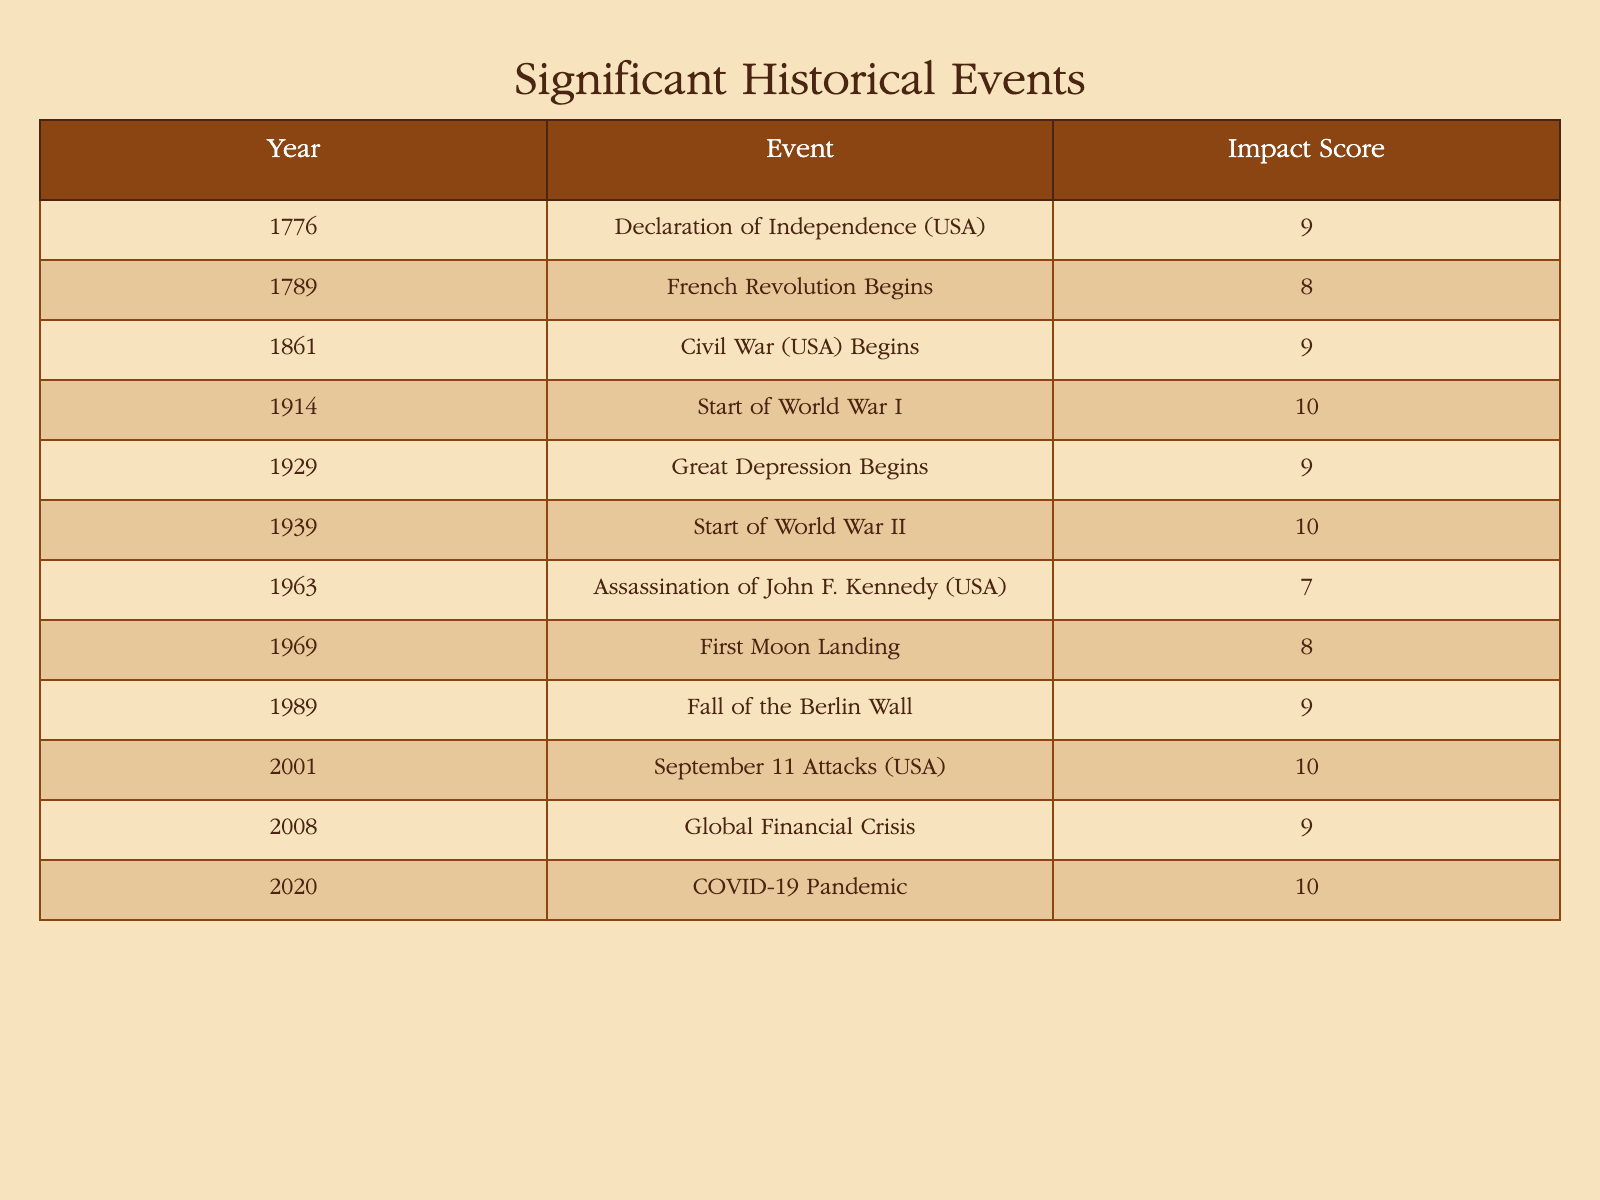What is the impact score of the Declaration of Independence? The table lists the event "Declaration of Independence (USA)" with an associated impact score of 9.
Answer: 9 In which year did World War I start? According to the table, the event "Start of World War I" is recorded in the year 1914.
Answer: 1914 How many events have an impact score of 10? The table shows three events with an impact score of 10: "Start of World War I," "Start of World War II," and "September 11 Attacks (USA)." Therefore, there are three events.
Answer: 3 What is the average impact score of the events listed in the table? The total of all impact scores is (9 + 8 + 9 + 10 + 9 + 10 + 7 + 8 + 9 + 10 + 9 + 10) =  112. There are 12 events, so the average is 112 / 12 = approximately 9.33.
Answer: 9.33 Was the Assassination of John F. Kennedy the event with the lowest impact score? The table lists the Assassination of John F. Kennedy (USA) with an impact score of 7, which is lower than the impact scores of all other events. Therefore, it is indeed the event with the lowest score.
Answer: Yes Which events occurred in the 20th century? The events that occurred in the 20th century, as seen in the table, include: "Start of World War I" (1914), "Great Depression Begins" (1929), "Start of World War II" (1939), "Assassination of John F. Kennedy" (1963), "First Moon Landing" (1969), "Fall of the Berlin Wall" (1989), "September 11 Attacks" (2001), and "Global Financial Crisis" (2008). There are eight events.
Answer: 8 How does the impact score of the Great Depression compare to that of the Fall of the Berlin Wall? The Great Depression has an impact score of 9, while the Fall of the Berlin Wall has an impact score of 9 as well. Therefore, they have the same score.
Answer: They are equal List the earliest event with an impact score of 9. The earliest event with an impact score of 9 is the "Declaration of Independence (USA)" from the year 1776.
Answer: Declaration of Independence (USA) 